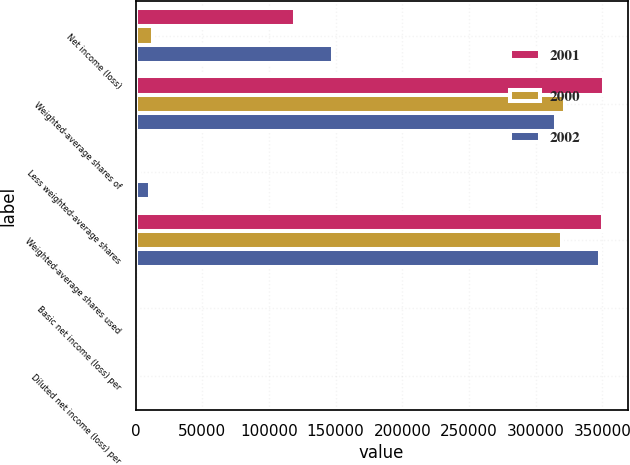<chart> <loc_0><loc_0><loc_500><loc_500><stacked_bar_chart><ecel><fcel>Net income (loss)<fcel>Weighted-average shares of<fcel>Less weighted-average shares<fcel>Weighted-average shares used<fcel>Basic net income (loss) per<fcel>Diluted net income (loss) per<nl><fcel>2001<fcel>119650<fcel>351289<fcel>594<fcel>350695<fcel>0.34<fcel>0.34<nl><fcel>2000<fcel>13417<fcel>321625<fcel>2247<fcel>319378<fcel>0.04<fcel>0.04<nl><fcel>2002<fcel>147916<fcel>315252<fcel>10871<fcel>347858<fcel>0.49<fcel>0.43<nl></chart> 